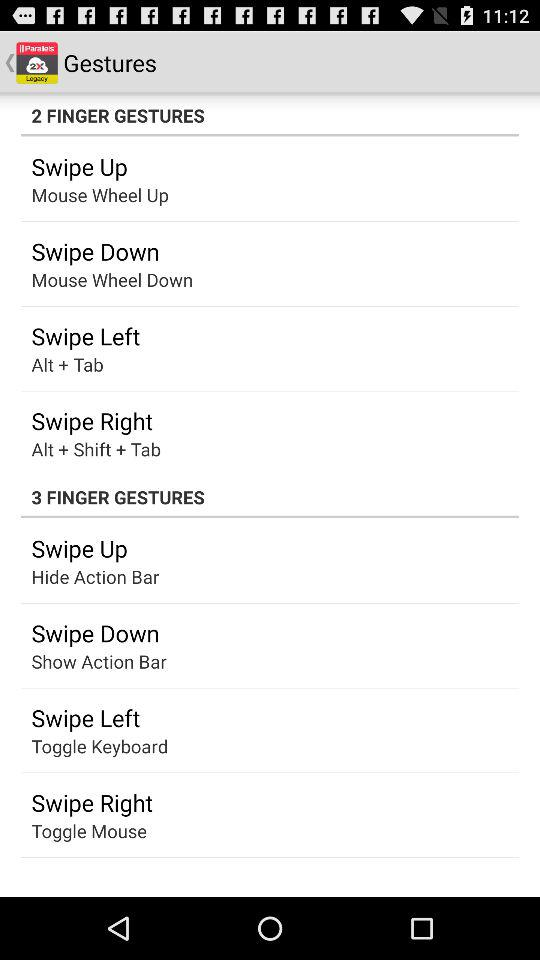What is the gesture of "Alt + Tab"? The gesture of "Alt + Tab" is "Swipe Left". 